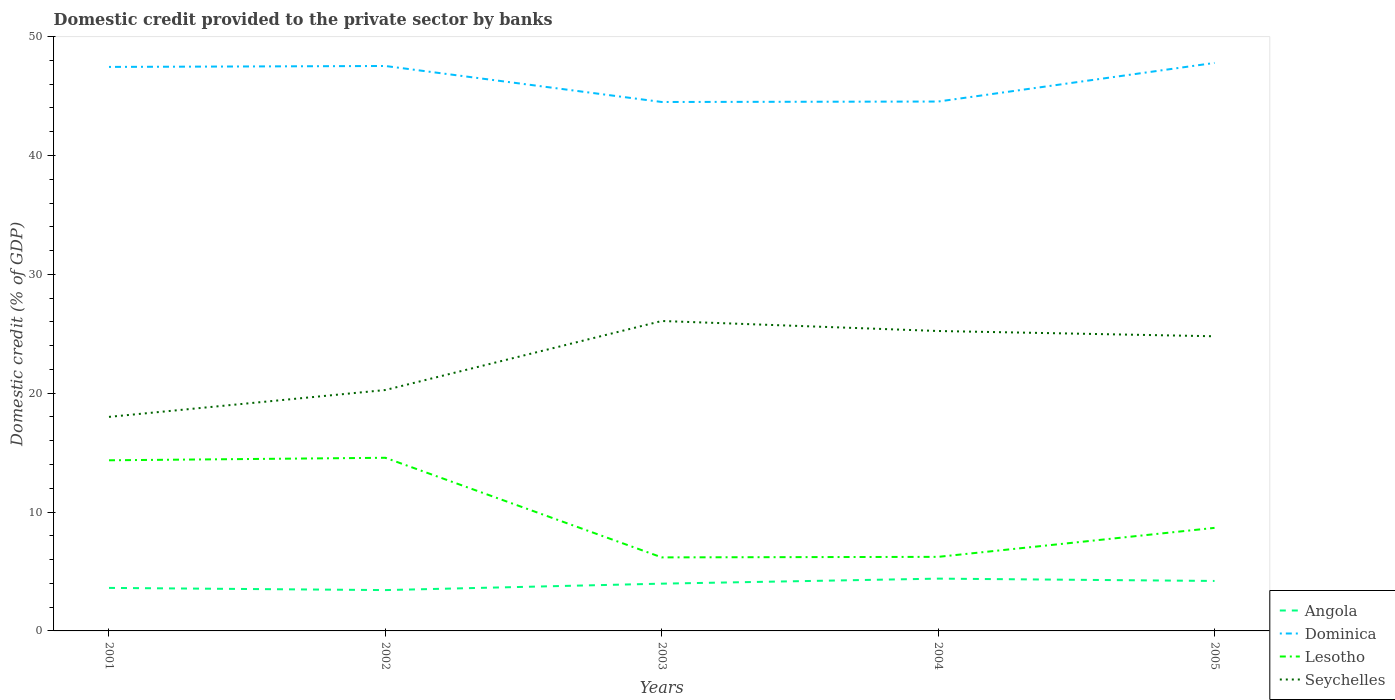Is the number of lines equal to the number of legend labels?
Ensure brevity in your answer.  Yes. Across all years, what is the maximum domestic credit provided to the private sector by banks in Lesotho?
Offer a very short reply. 6.19. What is the total domestic credit provided to the private sector by banks in Dominica in the graph?
Provide a short and direct response. -0.04. What is the difference between the highest and the second highest domestic credit provided to the private sector by banks in Lesotho?
Your answer should be compact. 8.38. How many lines are there?
Your answer should be compact. 4. What is the difference between two consecutive major ticks on the Y-axis?
Ensure brevity in your answer.  10. Does the graph contain any zero values?
Offer a terse response. No. Does the graph contain grids?
Keep it short and to the point. No. Where does the legend appear in the graph?
Offer a very short reply. Bottom right. How many legend labels are there?
Your answer should be very brief. 4. What is the title of the graph?
Give a very brief answer. Domestic credit provided to the private sector by banks. Does "Caribbean small states" appear as one of the legend labels in the graph?
Offer a very short reply. No. What is the label or title of the Y-axis?
Offer a terse response. Domestic credit (% of GDP). What is the Domestic credit (% of GDP) of Angola in 2001?
Provide a succinct answer. 3.62. What is the Domestic credit (% of GDP) of Dominica in 2001?
Offer a very short reply. 47.45. What is the Domestic credit (% of GDP) of Lesotho in 2001?
Provide a short and direct response. 14.36. What is the Domestic credit (% of GDP) in Seychelles in 2001?
Make the answer very short. 18.01. What is the Domestic credit (% of GDP) in Angola in 2002?
Make the answer very short. 3.44. What is the Domestic credit (% of GDP) of Dominica in 2002?
Your response must be concise. 47.53. What is the Domestic credit (% of GDP) in Lesotho in 2002?
Your answer should be compact. 14.57. What is the Domestic credit (% of GDP) of Seychelles in 2002?
Offer a terse response. 20.27. What is the Domestic credit (% of GDP) of Angola in 2003?
Your answer should be compact. 3.98. What is the Domestic credit (% of GDP) in Dominica in 2003?
Make the answer very short. 44.5. What is the Domestic credit (% of GDP) in Lesotho in 2003?
Offer a very short reply. 6.19. What is the Domestic credit (% of GDP) of Seychelles in 2003?
Your response must be concise. 26.07. What is the Domestic credit (% of GDP) of Angola in 2004?
Your answer should be very brief. 4.4. What is the Domestic credit (% of GDP) in Dominica in 2004?
Make the answer very short. 44.54. What is the Domestic credit (% of GDP) in Lesotho in 2004?
Make the answer very short. 6.23. What is the Domestic credit (% of GDP) of Seychelles in 2004?
Ensure brevity in your answer.  25.23. What is the Domestic credit (% of GDP) in Angola in 2005?
Ensure brevity in your answer.  4.2. What is the Domestic credit (% of GDP) in Dominica in 2005?
Ensure brevity in your answer.  47.78. What is the Domestic credit (% of GDP) of Lesotho in 2005?
Your answer should be very brief. 8.67. What is the Domestic credit (% of GDP) of Seychelles in 2005?
Provide a short and direct response. 24.79. Across all years, what is the maximum Domestic credit (% of GDP) of Angola?
Provide a short and direct response. 4.4. Across all years, what is the maximum Domestic credit (% of GDP) in Dominica?
Make the answer very short. 47.78. Across all years, what is the maximum Domestic credit (% of GDP) of Lesotho?
Keep it short and to the point. 14.57. Across all years, what is the maximum Domestic credit (% of GDP) of Seychelles?
Your answer should be compact. 26.07. Across all years, what is the minimum Domestic credit (% of GDP) in Angola?
Offer a very short reply. 3.44. Across all years, what is the minimum Domestic credit (% of GDP) in Dominica?
Offer a terse response. 44.5. Across all years, what is the minimum Domestic credit (% of GDP) of Lesotho?
Your answer should be very brief. 6.19. Across all years, what is the minimum Domestic credit (% of GDP) in Seychelles?
Your answer should be very brief. 18.01. What is the total Domestic credit (% of GDP) in Angola in the graph?
Offer a very short reply. 19.63. What is the total Domestic credit (% of GDP) of Dominica in the graph?
Your answer should be compact. 231.79. What is the total Domestic credit (% of GDP) in Lesotho in the graph?
Your answer should be compact. 50.01. What is the total Domestic credit (% of GDP) of Seychelles in the graph?
Your answer should be compact. 114.37. What is the difference between the Domestic credit (% of GDP) of Angola in 2001 and that in 2002?
Provide a succinct answer. 0.18. What is the difference between the Domestic credit (% of GDP) of Dominica in 2001 and that in 2002?
Make the answer very short. -0.08. What is the difference between the Domestic credit (% of GDP) in Lesotho in 2001 and that in 2002?
Your answer should be very brief. -0.21. What is the difference between the Domestic credit (% of GDP) of Seychelles in 2001 and that in 2002?
Provide a short and direct response. -2.26. What is the difference between the Domestic credit (% of GDP) of Angola in 2001 and that in 2003?
Ensure brevity in your answer.  -0.36. What is the difference between the Domestic credit (% of GDP) in Dominica in 2001 and that in 2003?
Offer a terse response. 2.95. What is the difference between the Domestic credit (% of GDP) of Lesotho in 2001 and that in 2003?
Offer a very short reply. 8.17. What is the difference between the Domestic credit (% of GDP) of Seychelles in 2001 and that in 2003?
Your response must be concise. -8.07. What is the difference between the Domestic credit (% of GDP) of Angola in 2001 and that in 2004?
Make the answer very short. -0.78. What is the difference between the Domestic credit (% of GDP) in Dominica in 2001 and that in 2004?
Provide a short and direct response. 2.91. What is the difference between the Domestic credit (% of GDP) of Lesotho in 2001 and that in 2004?
Give a very brief answer. 8.12. What is the difference between the Domestic credit (% of GDP) in Seychelles in 2001 and that in 2004?
Your response must be concise. -7.22. What is the difference between the Domestic credit (% of GDP) of Angola in 2001 and that in 2005?
Your response must be concise. -0.59. What is the difference between the Domestic credit (% of GDP) in Dominica in 2001 and that in 2005?
Keep it short and to the point. -0.34. What is the difference between the Domestic credit (% of GDP) in Lesotho in 2001 and that in 2005?
Keep it short and to the point. 5.69. What is the difference between the Domestic credit (% of GDP) in Seychelles in 2001 and that in 2005?
Ensure brevity in your answer.  -6.78. What is the difference between the Domestic credit (% of GDP) of Angola in 2002 and that in 2003?
Offer a very short reply. -0.54. What is the difference between the Domestic credit (% of GDP) in Dominica in 2002 and that in 2003?
Keep it short and to the point. 3.03. What is the difference between the Domestic credit (% of GDP) of Lesotho in 2002 and that in 2003?
Keep it short and to the point. 8.38. What is the difference between the Domestic credit (% of GDP) of Seychelles in 2002 and that in 2003?
Provide a succinct answer. -5.81. What is the difference between the Domestic credit (% of GDP) of Angola in 2002 and that in 2004?
Provide a short and direct response. -0.96. What is the difference between the Domestic credit (% of GDP) in Dominica in 2002 and that in 2004?
Offer a terse response. 2.99. What is the difference between the Domestic credit (% of GDP) in Lesotho in 2002 and that in 2004?
Give a very brief answer. 8.34. What is the difference between the Domestic credit (% of GDP) of Seychelles in 2002 and that in 2004?
Your answer should be compact. -4.96. What is the difference between the Domestic credit (% of GDP) in Angola in 2002 and that in 2005?
Offer a terse response. -0.77. What is the difference between the Domestic credit (% of GDP) in Dominica in 2002 and that in 2005?
Provide a succinct answer. -0.26. What is the difference between the Domestic credit (% of GDP) of Lesotho in 2002 and that in 2005?
Ensure brevity in your answer.  5.9. What is the difference between the Domestic credit (% of GDP) of Seychelles in 2002 and that in 2005?
Make the answer very short. -4.52. What is the difference between the Domestic credit (% of GDP) in Angola in 2003 and that in 2004?
Offer a very short reply. -0.42. What is the difference between the Domestic credit (% of GDP) in Dominica in 2003 and that in 2004?
Give a very brief answer. -0.04. What is the difference between the Domestic credit (% of GDP) in Lesotho in 2003 and that in 2004?
Ensure brevity in your answer.  -0.04. What is the difference between the Domestic credit (% of GDP) in Seychelles in 2003 and that in 2004?
Provide a succinct answer. 0.84. What is the difference between the Domestic credit (% of GDP) in Angola in 2003 and that in 2005?
Provide a short and direct response. -0.23. What is the difference between the Domestic credit (% of GDP) in Dominica in 2003 and that in 2005?
Offer a very short reply. -3.29. What is the difference between the Domestic credit (% of GDP) in Lesotho in 2003 and that in 2005?
Your answer should be compact. -2.48. What is the difference between the Domestic credit (% of GDP) in Seychelles in 2003 and that in 2005?
Keep it short and to the point. 1.29. What is the difference between the Domestic credit (% of GDP) in Angola in 2004 and that in 2005?
Make the answer very short. 0.2. What is the difference between the Domestic credit (% of GDP) of Dominica in 2004 and that in 2005?
Give a very brief answer. -3.25. What is the difference between the Domestic credit (% of GDP) in Lesotho in 2004 and that in 2005?
Give a very brief answer. -2.44. What is the difference between the Domestic credit (% of GDP) in Seychelles in 2004 and that in 2005?
Your answer should be very brief. 0.44. What is the difference between the Domestic credit (% of GDP) of Angola in 2001 and the Domestic credit (% of GDP) of Dominica in 2002?
Your answer should be very brief. -43.91. What is the difference between the Domestic credit (% of GDP) of Angola in 2001 and the Domestic credit (% of GDP) of Lesotho in 2002?
Offer a very short reply. -10.95. What is the difference between the Domestic credit (% of GDP) of Angola in 2001 and the Domestic credit (% of GDP) of Seychelles in 2002?
Your response must be concise. -16.65. What is the difference between the Domestic credit (% of GDP) of Dominica in 2001 and the Domestic credit (% of GDP) of Lesotho in 2002?
Offer a terse response. 32.88. What is the difference between the Domestic credit (% of GDP) in Dominica in 2001 and the Domestic credit (% of GDP) in Seychelles in 2002?
Give a very brief answer. 27.18. What is the difference between the Domestic credit (% of GDP) in Lesotho in 2001 and the Domestic credit (% of GDP) in Seychelles in 2002?
Ensure brevity in your answer.  -5.91. What is the difference between the Domestic credit (% of GDP) of Angola in 2001 and the Domestic credit (% of GDP) of Dominica in 2003?
Give a very brief answer. -40.88. What is the difference between the Domestic credit (% of GDP) of Angola in 2001 and the Domestic credit (% of GDP) of Lesotho in 2003?
Provide a short and direct response. -2.57. What is the difference between the Domestic credit (% of GDP) in Angola in 2001 and the Domestic credit (% of GDP) in Seychelles in 2003?
Offer a terse response. -22.46. What is the difference between the Domestic credit (% of GDP) of Dominica in 2001 and the Domestic credit (% of GDP) of Lesotho in 2003?
Make the answer very short. 41.26. What is the difference between the Domestic credit (% of GDP) in Dominica in 2001 and the Domestic credit (% of GDP) in Seychelles in 2003?
Offer a terse response. 21.37. What is the difference between the Domestic credit (% of GDP) of Lesotho in 2001 and the Domestic credit (% of GDP) of Seychelles in 2003?
Offer a very short reply. -11.72. What is the difference between the Domestic credit (% of GDP) of Angola in 2001 and the Domestic credit (% of GDP) of Dominica in 2004?
Your response must be concise. -40.92. What is the difference between the Domestic credit (% of GDP) of Angola in 2001 and the Domestic credit (% of GDP) of Lesotho in 2004?
Give a very brief answer. -2.61. What is the difference between the Domestic credit (% of GDP) of Angola in 2001 and the Domestic credit (% of GDP) of Seychelles in 2004?
Your answer should be very brief. -21.61. What is the difference between the Domestic credit (% of GDP) of Dominica in 2001 and the Domestic credit (% of GDP) of Lesotho in 2004?
Your answer should be compact. 41.22. What is the difference between the Domestic credit (% of GDP) of Dominica in 2001 and the Domestic credit (% of GDP) of Seychelles in 2004?
Ensure brevity in your answer.  22.22. What is the difference between the Domestic credit (% of GDP) of Lesotho in 2001 and the Domestic credit (% of GDP) of Seychelles in 2004?
Your answer should be very brief. -10.88. What is the difference between the Domestic credit (% of GDP) in Angola in 2001 and the Domestic credit (% of GDP) in Dominica in 2005?
Provide a short and direct response. -44.17. What is the difference between the Domestic credit (% of GDP) in Angola in 2001 and the Domestic credit (% of GDP) in Lesotho in 2005?
Your answer should be compact. -5.05. What is the difference between the Domestic credit (% of GDP) of Angola in 2001 and the Domestic credit (% of GDP) of Seychelles in 2005?
Ensure brevity in your answer.  -21.17. What is the difference between the Domestic credit (% of GDP) of Dominica in 2001 and the Domestic credit (% of GDP) of Lesotho in 2005?
Your response must be concise. 38.78. What is the difference between the Domestic credit (% of GDP) in Dominica in 2001 and the Domestic credit (% of GDP) in Seychelles in 2005?
Your response must be concise. 22.66. What is the difference between the Domestic credit (% of GDP) of Lesotho in 2001 and the Domestic credit (% of GDP) of Seychelles in 2005?
Give a very brief answer. -10.43. What is the difference between the Domestic credit (% of GDP) of Angola in 2002 and the Domestic credit (% of GDP) of Dominica in 2003?
Your response must be concise. -41.06. What is the difference between the Domestic credit (% of GDP) in Angola in 2002 and the Domestic credit (% of GDP) in Lesotho in 2003?
Offer a terse response. -2.75. What is the difference between the Domestic credit (% of GDP) of Angola in 2002 and the Domestic credit (% of GDP) of Seychelles in 2003?
Make the answer very short. -22.64. What is the difference between the Domestic credit (% of GDP) in Dominica in 2002 and the Domestic credit (% of GDP) in Lesotho in 2003?
Make the answer very short. 41.34. What is the difference between the Domestic credit (% of GDP) of Dominica in 2002 and the Domestic credit (% of GDP) of Seychelles in 2003?
Ensure brevity in your answer.  21.45. What is the difference between the Domestic credit (% of GDP) of Lesotho in 2002 and the Domestic credit (% of GDP) of Seychelles in 2003?
Give a very brief answer. -11.51. What is the difference between the Domestic credit (% of GDP) of Angola in 2002 and the Domestic credit (% of GDP) of Dominica in 2004?
Make the answer very short. -41.1. What is the difference between the Domestic credit (% of GDP) in Angola in 2002 and the Domestic credit (% of GDP) in Lesotho in 2004?
Provide a short and direct response. -2.8. What is the difference between the Domestic credit (% of GDP) in Angola in 2002 and the Domestic credit (% of GDP) in Seychelles in 2004?
Your answer should be very brief. -21.8. What is the difference between the Domestic credit (% of GDP) in Dominica in 2002 and the Domestic credit (% of GDP) in Lesotho in 2004?
Your answer should be very brief. 41.3. What is the difference between the Domestic credit (% of GDP) in Dominica in 2002 and the Domestic credit (% of GDP) in Seychelles in 2004?
Ensure brevity in your answer.  22.3. What is the difference between the Domestic credit (% of GDP) of Lesotho in 2002 and the Domestic credit (% of GDP) of Seychelles in 2004?
Provide a short and direct response. -10.67. What is the difference between the Domestic credit (% of GDP) in Angola in 2002 and the Domestic credit (% of GDP) in Dominica in 2005?
Provide a short and direct response. -44.35. What is the difference between the Domestic credit (% of GDP) in Angola in 2002 and the Domestic credit (% of GDP) in Lesotho in 2005?
Provide a short and direct response. -5.23. What is the difference between the Domestic credit (% of GDP) of Angola in 2002 and the Domestic credit (% of GDP) of Seychelles in 2005?
Give a very brief answer. -21.35. What is the difference between the Domestic credit (% of GDP) of Dominica in 2002 and the Domestic credit (% of GDP) of Lesotho in 2005?
Your answer should be compact. 38.86. What is the difference between the Domestic credit (% of GDP) in Dominica in 2002 and the Domestic credit (% of GDP) in Seychelles in 2005?
Keep it short and to the point. 22.74. What is the difference between the Domestic credit (% of GDP) of Lesotho in 2002 and the Domestic credit (% of GDP) of Seychelles in 2005?
Your response must be concise. -10.22. What is the difference between the Domestic credit (% of GDP) in Angola in 2003 and the Domestic credit (% of GDP) in Dominica in 2004?
Make the answer very short. -40.56. What is the difference between the Domestic credit (% of GDP) in Angola in 2003 and the Domestic credit (% of GDP) in Lesotho in 2004?
Provide a short and direct response. -2.26. What is the difference between the Domestic credit (% of GDP) of Angola in 2003 and the Domestic credit (% of GDP) of Seychelles in 2004?
Provide a short and direct response. -21.26. What is the difference between the Domestic credit (% of GDP) of Dominica in 2003 and the Domestic credit (% of GDP) of Lesotho in 2004?
Provide a short and direct response. 38.27. What is the difference between the Domestic credit (% of GDP) of Dominica in 2003 and the Domestic credit (% of GDP) of Seychelles in 2004?
Keep it short and to the point. 19.27. What is the difference between the Domestic credit (% of GDP) of Lesotho in 2003 and the Domestic credit (% of GDP) of Seychelles in 2004?
Ensure brevity in your answer.  -19.05. What is the difference between the Domestic credit (% of GDP) in Angola in 2003 and the Domestic credit (% of GDP) in Dominica in 2005?
Ensure brevity in your answer.  -43.81. What is the difference between the Domestic credit (% of GDP) of Angola in 2003 and the Domestic credit (% of GDP) of Lesotho in 2005?
Offer a very short reply. -4.69. What is the difference between the Domestic credit (% of GDP) in Angola in 2003 and the Domestic credit (% of GDP) in Seychelles in 2005?
Make the answer very short. -20.81. What is the difference between the Domestic credit (% of GDP) in Dominica in 2003 and the Domestic credit (% of GDP) in Lesotho in 2005?
Provide a short and direct response. 35.83. What is the difference between the Domestic credit (% of GDP) of Dominica in 2003 and the Domestic credit (% of GDP) of Seychelles in 2005?
Offer a terse response. 19.71. What is the difference between the Domestic credit (% of GDP) of Lesotho in 2003 and the Domestic credit (% of GDP) of Seychelles in 2005?
Your response must be concise. -18.6. What is the difference between the Domestic credit (% of GDP) of Angola in 2004 and the Domestic credit (% of GDP) of Dominica in 2005?
Keep it short and to the point. -43.38. What is the difference between the Domestic credit (% of GDP) of Angola in 2004 and the Domestic credit (% of GDP) of Lesotho in 2005?
Your answer should be very brief. -4.27. What is the difference between the Domestic credit (% of GDP) in Angola in 2004 and the Domestic credit (% of GDP) in Seychelles in 2005?
Your answer should be compact. -20.39. What is the difference between the Domestic credit (% of GDP) of Dominica in 2004 and the Domestic credit (% of GDP) of Lesotho in 2005?
Your response must be concise. 35.87. What is the difference between the Domestic credit (% of GDP) of Dominica in 2004 and the Domestic credit (% of GDP) of Seychelles in 2005?
Keep it short and to the point. 19.75. What is the difference between the Domestic credit (% of GDP) of Lesotho in 2004 and the Domestic credit (% of GDP) of Seychelles in 2005?
Provide a succinct answer. -18.56. What is the average Domestic credit (% of GDP) of Angola per year?
Your response must be concise. 3.93. What is the average Domestic credit (% of GDP) of Dominica per year?
Your response must be concise. 46.36. What is the average Domestic credit (% of GDP) in Lesotho per year?
Give a very brief answer. 10. What is the average Domestic credit (% of GDP) of Seychelles per year?
Your response must be concise. 22.87. In the year 2001, what is the difference between the Domestic credit (% of GDP) in Angola and Domestic credit (% of GDP) in Dominica?
Your answer should be compact. -43.83. In the year 2001, what is the difference between the Domestic credit (% of GDP) in Angola and Domestic credit (% of GDP) in Lesotho?
Provide a short and direct response. -10.74. In the year 2001, what is the difference between the Domestic credit (% of GDP) in Angola and Domestic credit (% of GDP) in Seychelles?
Keep it short and to the point. -14.39. In the year 2001, what is the difference between the Domestic credit (% of GDP) of Dominica and Domestic credit (% of GDP) of Lesotho?
Ensure brevity in your answer.  33.09. In the year 2001, what is the difference between the Domestic credit (% of GDP) of Dominica and Domestic credit (% of GDP) of Seychelles?
Your response must be concise. 29.44. In the year 2001, what is the difference between the Domestic credit (% of GDP) in Lesotho and Domestic credit (% of GDP) in Seychelles?
Offer a very short reply. -3.65. In the year 2002, what is the difference between the Domestic credit (% of GDP) in Angola and Domestic credit (% of GDP) in Dominica?
Your answer should be very brief. -44.09. In the year 2002, what is the difference between the Domestic credit (% of GDP) of Angola and Domestic credit (% of GDP) of Lesotho?
Offer a terse response. -11.13. In the year 2002, what is the difference between the Domestic credit (% of GDP) in Angola and Domestic credit (% of GDP) in Seychelles?
Provide a short and direct response. -16.83. In the year 2002, what is the difference between the Domestic credit (% of GDP) of Dominica and Domestic credit (% of GDP) of Lesotho?
Make the answer very short. 32.96. In the year 2002, what is the difference between the Domestic credit (% of GDP) in Dominica and Domestic credit (% of GDP) in Seychelles?
Ensure brevity in your answer.  27.26. In the year 2002, what is the difference between the Domestic credit (% of GDP) of Lesotho and Domestic credit (% of GDP) of Seychelles?
Your answer should be compact. -5.7. In the year 2003, what is the difference between the Domestic credit (% of GDP) of Angola and Domestic credit (% of GDP) of Dominica?
Give a very brief answer. -40.52. In the year 2003, what is the difference between the Domestic credit (% of GDP) of Angola and Domestic credit (% of GDP) of Lesotho?
Your response must be concise. -2.21. In the year 2003, what is the difference between the Domestic credit (% of GDP) of Angola and Domestic credit (% of GDP) of Seychelles?
Offer a terse response. -22.1. In the year 2003, what is the difference between the Domestic credit (% of GDP) of Dominica and Domestic credit (% of GDP) of Lesotho?
Ensure brevity in your answer.  38.31. In the year 2003, what is the difference between the Domestic credit (% of GDP) in Dominica and Domestic credit (% of GDP) in Seychelles?
Keep it short and to the point. 18.42. In the year 2003, what is the difference between the Domestic credit (% of GDP) in Lesotho and Domestic credit (% of GDP) in Seychelles?
Give a very brief answer. -19.89. In the year 2004, what is the difference between the Domestic credit (% of GDP) in Angola and Domestic credit (% of GDP) in Dominica?
Your response must be concise. -40.14. In the year 2004, what is the difference between the Domestic credit (% of GDP) in Angola and Domestic credit (% of GDP) in Lesotho?
Provide a succinct answer. -1.83. In the year 2004, what is the difference between the Domestic credit (% of GDP) in Angola and Domestic credit (% of GDP) in Seychelles?
Give a very brief answer. -20.83. In the year 2004, what is the difference between the Domestic credit (% of GDP) of Dominica and Domestic credit (% of GDP) of Lesotho?
Offer a terse response. 38.31. In the year 2004, what is the difference between the Domestic credit (% of GDP) in Dominica and Domestic credit (% of GDP) in Seychelles?
Provide a succinct answer. 19.3. In the year 2004, what is the difference between the Domestic credit (% of GDP) of Lesotho and Domestic credit (% of GDP) of Seychelles?
Your answer should be compact. -19. In the year 2005, what is the difference between the Domestic credit (% of GDP) of Angola and Domestic credit (% of GDP) of Dominica?
Your answer should be very brief. -43.58. In the year 2005, what is the difference between the Domestic credit (% of GDP) in Angola and Domestic credit (% of GDP) in Lesotho?
Make the answer very short. -4.47. In the year 2005, what is the difference between the Domestic credit (% of GDP) in Angola and Domestic credit (% of GDP) in Seychelles?
Ensure brevity in your answer.  -20.58. In the year 2005, what is the difference between the Domestic credit (% of GDP) of Dominica and Domestic credit (% of GDP) of Lesotho?
Make the answer very short. 39.12. In the year 2005, what is the difference between the Domestic credit (% of GDP) of Dominica and Domestic credit (% of GDP) of Seychelles?
Provide a short and direct response. 23. In the year 2005, what is the difference between the Domestic credit (% of GDP) in Lesotho and Domestic credit (% of GDP) in Seychelles?
Provide a short and direct response. -16.12. What is the ratio of the Domestic credit (% of GDP) of Angola in 2001 to that in 2002?
Ensure brevity in your answer.  1.05. What is the ratio of the Domestic credit (% of GDP) of Lesotho in 2001 to that in 2002?
Make the answer very short. 0.99. What is the ratio of the Domestic credit (% of GDP) in Seychelles in 2001 to that in 2002?
Make the answer very short. 0.89. What is the ratio of the Domestic credit (% of GDP) in Angola in 2001 to that in 2003?
Ensure brevity in your answer.  0.91. What is the ratio of the Domestic credit (% of GDP) of Dominica in 2001 to that in 2003?
Your response must be concise. 1.07. What is the ratio of the Domestic credit (% of GDP) in Lesotho in 2001 to that in 2003?
Keep it short and to the point. 2.32. What is the ratio of the Domestic credit (% of GDP) of Seychelles in 2001 to that in 2003?
Offer a terse response. 0.69. What is the ratio of the Domestic credit (% of GDP) of Angola in 2001 to that in 2004?
Ensure brevity in your answer.  0.82. What is the ratio of the Domestic credit (% of GDP) in Dominica in 2001 to that in 2004?
Your response must be concise. 1.07. What is the ratio of the Domestic credit (% of GDP) in Lesotho in 2001 to that in 2004?
Ensure brevity in your answer.  2.3. What is the ratio of the Domestic credit (% of GDP) of Seychelles in 2001 to that in 2004?
Ensure brevity in your answer.  0.71. What is the ratio of the Domestic credit (% of GDP) in Angola in 2001 to that in 2005?
Provide a succinct answer. 0.86. What is the ratio of the Domestic credit (% of GDP) of Dominica in 2001 to that in 2005?
Ensure brevity in your answer.  0.99. What is the ratio of the Domestic credit (% of GDP) in Lesotho in 2001 to that in 2005?
Your response must be concise. 1.66. What is the ratio of the Domestic credit (% of GDP) in Seychelles in 2001 to that in 2005?
Your answer should be very brief. 0.73. What is the ratio of the Domestic credit (% of GDP) in Angola in 2002 to that in 2003?
Make the answer very short. 0.86. What is the ratio of the Domestic credit (% of GDP) of Dominica in 2002 to that in 2003?
Provide a short and direct response. 1.07. What is the ratio of the Domestic credit (% of GDP) of Lesotho in 2002 to that in 2003?
Offer a very short reply. 2.35. What is the ratio of the Domestic credit (% of GDP) in Seychelles in 2002 to that in 2003?
Your answer should be compact. 0.78. What is the ratio of the Domestic credit (% of GDP) of Angola in 2002 to that in 2004?
Your answer should be very brief. 0.78. What is the ratio of the Domestic credit (% of GDP) in Dominica in 2002 to that in 2004?
Offer a very short reply. 1.07. What is the ratio of the Domestic credit (% of GDP) of Lesotho in 2002 to that in 2004?
Your answer should be very brief. 2.34. What is the ratio of the Domestic credit (% of GDP) in Seychelles in 2002 to that in 2004?
Your answer should be very brief. 0.8. What is the ratio of the Domestic credit (% of GDP) of Angola in 2002 to that in 2005?
Provide a succinct answer. 0.82. What is the ratio of the Domestic credit (% of GDP) of Lesotho in 2002 to that in 2005?
Provide a succinct answer. 1.68. What is the ratio of the Domestic credit (% of GDP) in Seychelles in 2002 to that in 2005?
Offer a very short reply. 0.82. What is the ratio of the Domestic credit (% of GDP) in Angola in 2003 to that in 2004?
Ensure brevity in your answer.  0.9. What is the ratio of the Domestic credit (% of GDP) of Seychelles in 2003 to that in 2004?
Your answer should be very brief. 1.03. What is the ratio of the Domestic credit (% of GDP) in Angola in 2003 to that in 2005?
Offer a very short reply. 0.95. What is the ratio of the Domestic credit (% of GDP) of Dominica in 2003 to that in 2005?
Offer a terse response. 0.93. What is the ratio of the Domestic credit (% of GDP) of Lesotho in 2003 to that in 2005?
Provide a short and direct response. 0.71. What is the ratio of the Domestic credit (% of GDP) in Seychelles in 2003 to that in 2005?
Your answer should be compact. 1.05. What is the ratio of the Domestic credit (% of GDP) of Angola in 2004 to that in 2005?
Keep it short and to the point. 1.05. What is the ratio of the Domestic credit (% of GDP) in Dominica in 2004 to that in 2005?
Your answer should be very brief. 0.93. What is the ratio of the Domestic credit (% of GDP) in Lesotho in 2004 to that in 2005?
Your response must be concise. 0.72. What is the ratio of the Domestic credit (% of GDP) of Seychelles in 2004 to that in 2005?
Offer a very short reply. 1.02. What is the difference between the highest and the second highest Domestic credit (% of GDP) in Angola?
Make the answer very short. 0.2. What is the difference between the highest and the second highest Domestic credit (% of GDP) in Dominica?
Offer a very short reply. 0.26. What is the difference between the highest and the second highest Domestic credit (% of GDP) of Lesotho?
Keep it short and to the point. 0.21. What is the difference between the highest and the second highest Domestic credit (% of GDP) of Seychelles?
Ensure brevity in your answer.  0.84. What is the difference between the highest and the lowest Domestic credit (% of GDP) of Angola?
Offer a terse response. 0.96. What is the difference between the highest and the lowest Domestic credit (% of GDP) of Dominica?
Keep it short and to the point. 3.29. What is the difference between the highest and the lowest Domestic credit (% of GDP) of Lesotho?
Your answer should be compact. 8.38. What is the difference between the highest and the lowest Domestic credit (% of GDP) in Seychelles?
Your answer should be compact. 8.07. 